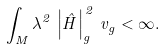<formula> <loc_0><loc_0><loc_500><loc_500>\int _ { M } \lambda ^ { 2 } \, \left | \hat { H } \right | ^ { \, 2 } _ { g } \, v _ { g } < \infty .</formula> 